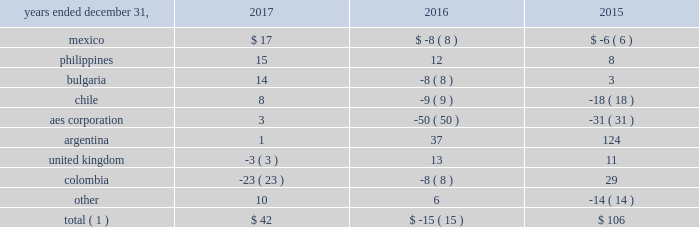Foreign currency transaction gains ( losses ) foreign currency transaction gains ( losses ) in millions were as follows: .
Total ( 1 ) $ 42 $ ( 15 ) $ 106 _____________________________ ( 1 ) includes gains of $ 21 million , $ 17 million and $ 247 million on foreign currency derivative contracts for the years ended december 31 , 2017 , 2016 and 2015 , respectively .
The company recognized net foreign currency transaction gains of $ 42 million for the year ended december 31 , 2017 primarily driven by transactions associated with vat activity in mexico , the amortization of frozen embedded derivatives in the philippines , and appreciation of the euro in bulgaria .
These gains were partially offset by unfavorable foreign currency derivatives in colombia .
The company recognized net foreign currency transaction losses of $ 15 million for the year ended december 31 , 2016 primarily due to remeasurement losses on intercompany notes , and losses on swaps and options at the aes corporation .
This loss was partially offset in argentina , mainly due to the favorable impact of foreign currency derivatives related to government receivables .
The company recognized net foreign currency transaction gains of $ 106 million for the year ended december 31 , 2015 primarily due to foreign currency derivatives related to government receivables in argentina and depreciation of the colombian peso in colombia .
These gains were partially offset due to decreases in the valuation of intercompany notes at the aes corporation and unfavorable devaluation of the chilean peso in chile .
Income tax expense income tax expense increased $ 958 million to $ 990 million in 2017 as compared to 2016 .
The company's effective tax rates were 128% ( 128 % ) and 17% ( 17 % ) for the years ended december 31 , 2017 and 2016 , respectively .
The net increase in the 2017 effective tax rate was due primarily to expense related to the u.s .
Tax reform one-time transition tax and remeasurement of deferred tax assets .
Further , the 2016 rate was impacted by the items described below .
Income tax expense decreased $ 380 million to $ 32 million in 2016 as compared to 2015 .
The company's effective tax rates were 17% ( 17 % ) and 42% ( 42 % ) for the years ended december 31 , 2016 and 2015 , respectively .
The net decrease in the 2016 effective tax rate was due , in part , to the 2016 asset impairments in the u.s. , as well as the devaluation of the peso in certain of our mexican subsidiaries and the release of valuation allowance at certain of our brazilian subsidiaries .
These favorable items were partially offset by the unfavorable impact of chilean income tax law reform enacted during the first quarter of 2016 .
Further , the 2015 rate was due , in part , to the nondeductible 2015 impairment of goodwill at dp&l and chilean withholding taxes offset by the release of valuation allowance at certain of our businesses in brazil , vietnam and the u.s .
See note 19 2014asset impairment expense included in item 8 . 2014financial statements and supplementary data of this form 10-k for additional information regarding the 2016 u.s .
Asset impairments .
See note 20 2014income taxes included in item 8 . 2014financial statements and supplementary data of this form 10-k for additional information regarding the 2016 chilean income tax law reform .
Our effective tax rate reflects the tax effect of significant operations outside the u.s. , which are generally taxed at rates different than the u.s .
Statutory rate .
Foreign earnings may be taxed at rates higher than the new u.s .
Corporate rate of 21% ( 21 % ) and a greater portion of our foreign earnings may be subject to current u.s .
Taxation under the new tax rules .
A future proportionate change in the composition of income before income taxes from foreign and domestic tax jurisdictions could impact our periodic effective tax rate .
The company also benefits from reduced tax rates in certain countries as a result of satisfying specific commitments regarding employment and capital investment .
See note 20 2014income taxes included in item 8 . 2014financial statements and supplementary data of this form 10-k for additional information regarding these reduced rates. .
In 2017 what percentage of foreign currency transaction gains were attributable to mexico? 
Computations: (17 / 42)
Answer: 0.40476. 